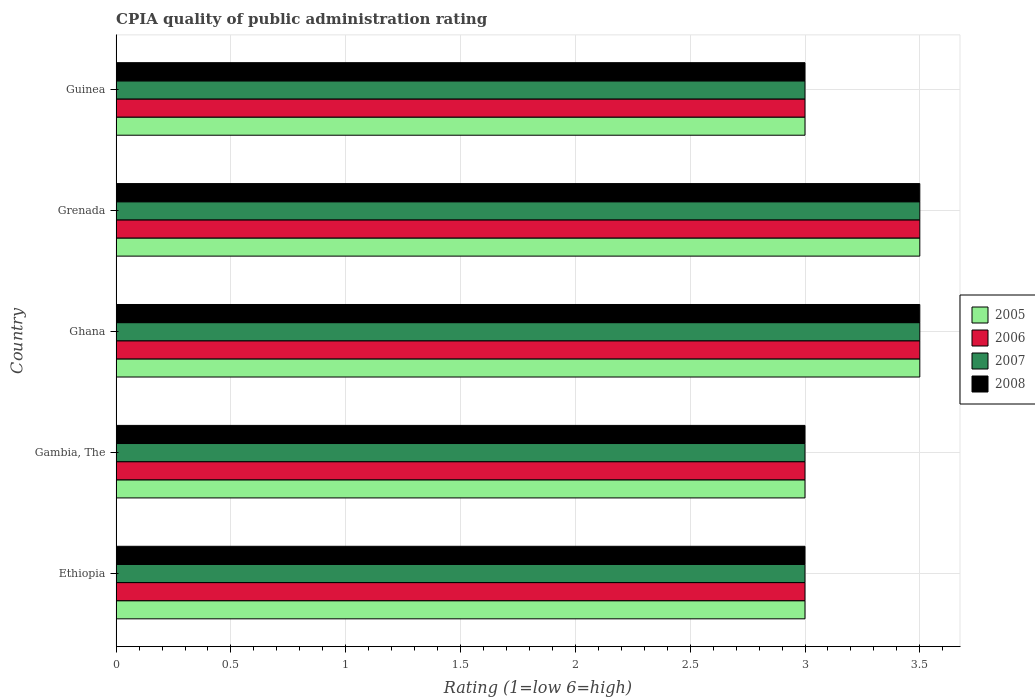Are the number of bars per tick equal to the number of legend labels?
Ensure brevity in your answer.  Yes. How many bars are there on the 4th tick from the top?
Make the answer very short. 4. How many bars are there on the 3rd tick from the bottom?
Give a very brief answer. 4. What is the label of the 5th group of bars from the top?
Keep it short and to the point. Ethiopia. In which country was the CPIA rating in 2006 maximum?
Your answer should be compact. Ghana. In which country was the CPIA rating in 2006 minimum?
Your answer should be very brief. Ethiopia. What is the total CPIA rating in 2005 in the graph?
Offer a terse response. 16. What is the difference between the CPIA rating in 2005 in Ghana and the CPIA rating in 2006 in Ethiopia?
Your response must be concise. 0.5. What is the average CPIA rating in 2008 per country?
Make the answer very short. 3.2. In how many countries, is the CPIA rating in 2008 greater than 1 ?
Ensure brevity in your answer.  5. What is the ratio of the CPIA rating in 2005 in Ethiopia to that in Ghana?
Provide a short and direct response. 0.86. Is the CPIA rating in 2007 in Ghana less than that in Grenada?
Your response must be concise. No. Is the sum of the CPIA rating in 2006 in Ethiopia and Grenada greater than the maximum CPIA rating in 2008 across all countries?
Make the answer very short. Yes. Is it the case that in every country, the sum of the CPIA rating in 2005 and CPIA rating in 2006 is greater than the sum of CPIA rating in 2008 and CPIA rating in 2007?
Offer a terse response. No. What does the 1st bar from the bottom in Grenada represents?
Offer a very short reply. 2005. How many bars are there?
Provide a succinct answer. 20. How many countries are there in the graph?
Provide a short and direct response. 5. Are the values on the major ticks of X-axis written in scientific E-notation?
Your response must be concise. No. Does the graph contain any zero values?
Keep it short and to the point. No. Does the graph contain grids?
Provide a short and direct response. Yes. What is the title of the graph?
Offer a terse response. CPIA quality of public administration rating. Does "2013" appear as one of the legend labels in the graph?
Give a very brief answer. No. What is the Rating (1=low 6=high) of 2005 in Ethiopia?
Offer a terse response. 3. What is the Rating (1=low 6=high) of 2008 in Ethiopia?
Your answer should be compact. 3. What is the Rating (1=low 6=high) in 2005 in Gambia, The?
Keep it short and to the point. 3. What is the Rating (1=low 6=high) of 2008 in Gambia, The?
Ensure brevity in your answer.  3. What is the Rating (1=low 6=high) of 2008 in Ghana?
Your answer should be very brief. 3.5. What is the Rating (1=low 6=high) of 2005 in Guinea?
Give a very brief answer. 3. What is the Rating (1=low 6=high) of 2007 in Guinea?
Your response must be concise. 3. Across all countries, what is the maximum Rating (1=low 6=high) of 2005?
Your response must be concise. 3.5. Across all countries, what is the maximum Rating (1=low 6=high) of 2006?
Give a very brief answer. 3.5. Across all countries, what is the maximum Rating (1=low 6=high) of 2008?
Your answer should be compact. 3.5. Across all countries, what is the minimum Rating (1=low 6=high) in 2006?
Ensure brevity in your answer.  3. Across all countries, what is the minimum Rating (1=low 6=high) in 2007?
Give a very brief answer. 3. Across all countries, what is the minimum Rating (1=low 6=high) of 2008?
Offer a terse response. 3. What is the total Rating (1=low 6=high) of 2005 in the graph?
Ensure brevity in your answer.  16. What is the total Rating (1=low 6=high) in 2006 in the graph?
Provide a short and direct response. 16. What is the total Rating (1=low 6=high) of 2007 in the graph?
Make the answer very short. 16. What is the total Rating (1=low 6=high) of 2008 in the graph?
Offer a terse response. 16. What is the difference between the Rating (1=low 6=high) of 2006 in Ethiopia and that in Gambia, The?
Your answer should be very brief. 0. What is the difference between the Rating (1=low 6=high) in 2007 in Ethiopia and that in Gambia, The?
Keep it short and to the point. 0. What is the difference between the Rating (1=low 6=high) in 2007 in Ethiopia and that in Ghana?
Make the answer very short. -0.5. What is the difference between the Rating (1=low 6=high) of 2005 in Ethiopia and that in Grenada?
Offer a very short reply. -0.5. What is the difference between the Rating (1=low 6=high) of 2006 in Ethiopia and that in Grenada?
Ensure brevity in your answer.  -0.5. What is the difference between the Rating (1=low 6=high) in 2007 in Ethiopia and that in Grenada?
Offer a very short reply. -0.5. What is the difference between the Rating (1=low 6=high) of 2005 in Ethiopia and that in Guinea?
Ensure brevity in your answer.  0. What is the difference between the Rating (1=low 6=high) in 2008 in Ethiopia and that in Guinea?
Provide a succinct answer. 0. What is the difference between the Rating (1=low 6=high) of 2006 in Gambia, The and that in Ghana?
Ensure brevity in your answer.  -0.5. What is the difference between the Rating (1=low 6=high) of 2007 in Gambia, The and that in Grenada?
Provide a short and direct response. -0.5. What is the difference between the Rating (1=low 6=high) in 2005 in Gambia, The and that in Guinea?
Offer a terse response. 0. What is the difference between the Rating (1=low 6=high) of 2005 in Ghana and that in Grenada?
Your answer should be compact. 0. What is the difference between the Rating (1=low 6=high) of 2007 in Ghana and that in Grenada?
Give a very brief answer. 0. What is the difference between the Rating (1=low 6=high) in 2007 in Ghana and that in Guinea?
Keep it short and to the point. 0.5. What is the difference between the Rating (1=low 6=high) in 2005 in Grenada and that in Guinea?
Provide a succinct answer. 0.5. What is the difference between the Rating (1=low 6=high) in 2007 in Grenada and that in Guinea?
Your answer should be compact. 0.5. What is the difference between the Rating (1=low 6=high) in 2005 in Ethiopia and the Rating (1=low 6=high) in 2006 in Gambia, The?
Make the answer very short. 0. What is the difference between the Rating (1=low 6=high) of 2005 in Ethiopia and the Rating (1=low 6=high) of 2007 in Gambia, The?
Provide a succinct answer. 0. What is the difference between the Rating (1=low 6=high) in 2006 in Ethiopia and the Rating (1=low 6=high) in 2007 in Gambia, The?
Your answer should be compact. 0. What is the difference between the Rating (1=low 6=high) in 2006 in Ethiopia and the Rating (1=low 6=high) in 2008 in Gambia, The?
Make the answer very short. 0. What is the difference between the Rating (1=low 6=high) of 2007 in Ethiopia and the Rating (1=low 6=high) of 2008 in Gambia, The?
Your answer should be compact. 0. What is the difference between the Rating (1=low 6=high) in 2005 in Ethiopia and the Rating (1=low 6=high) in 2007 in Ghana?
Provide a short and direct response. -0.5. What is the difference between the Rating (1=low 6=high) in 2006 in Ethiopia and the Rating (1=low 6=high) in 2007 in Ghana?
Your answer should be very brief. -0.5. What is the difference between the Rating (1=low 6=high) in 2006 in Ethiopia and the Rating (1=low 6=high) in 2008 in Ghana?
Give a very brief answer. -0.5. What is the difference between the Rating (1=low 6=high) of 2007 in Ethiopia and the Rating (1=low 6=high) of 2008 in Ghana?
Provide a succinct answer. -0.5. What is the difference between the Rating (1=low 6=high) in 2005 in Ethiopia and the Rating (1=low 6=high) in 2007 in Grenada?
Keep it short and to the point. -0.5. What is the difference between the Rating (1=low 6=high) in 2006 in Ethiopia and the Rating (1=low 6=high) in 2007 in Grenada?
Keep it short and to the point. -0.5. What is the difference between the Rating (1=low 6=high) in 2006 in Ethiopia and the Rating (1=low 6=high) in 2008 in Grenada?
Give a very brief answer. -0.5. What is the difference between the Rating (1=low 6=high) of 2007 in Ethiopia and the Rating (1=low 6=high) of 2008 in Grenada?
Make the answer very short. -0.5. What is the difference between the Rating (1=low 6=high) in 2005 in Ethiopia and the Rating (1=low 6=high) in 2007 in Guinea?
Your answer should be very brief. 0. What is the difference between the Rating (1=low 6=high) of 2005 in Ethiopia and the Rating (1=low 6=high) of 2008 in Guinea?
Make the answer very short. 0. What is the difference between the Rating (1=low 6=high) of 2006 in Ethiopia and the Rating (1=low 6=high) of 2007 in Guinea?
Ensure brevity in your answer.  0. What is the difference between the Rating (1=low 6=high) in 2007 in Gambia, The and the Rating (1=low 6=high) in 2008 in Ghana?
Your response must be concise. -0.5. What is the difference between the Rating (1=low 6=high) of 2005 in Gambia, The and the Rating (1=low 6=high) of 2006 in Grenada?
Offer a very short reply. -0.5. What is the difference between the Rating (1=low 6=high) in 2005 in Gambia, The and the Rating (1=low 6=high) in 2007 in Grenada?
Ensure brevity in your answer.  -0.5. What is the difference between the Rating (1=low 6=high) in 2005 in Ghana and the Rating (1=low 6=high) in 2006 in Grenada?
Offer a terse response. 0. What is the difference between the Rating (1=low 6=high) in 2005 in Ghana and the Rating (1=low 6=high) in 2007 in Grenada?
Your response must be concise. 0. What is the difference between the Rating (1=low 6=high) of 2006 in Ghana and the Rating (1=low 6=high) of 2008 in Grenada?
Provide a succinct answer. 0. What is the difference between the Rating (1=low 6=high) in 2007 in Ghana and the Rating (1=low 6=high) in 2008 in Grenada?
Provide a short and direct response. 0. What is the difference between the Rating (1=low 6=high) in 2005 in Ghana and the Rating (1=low 6=high) in 2006 in Guinea?
Offer a terse response. 0.5. What is the difference between the Rating (1=low 6=high) in 2005 in Ghana and the Rating (1=low 6=high) in 2007 in Guinea?
Ensure brevity in your answer.  0.5. What is the difference between the Rating (1=low 6=high) in 2005 in Ghana and the Rating (1=low 6=high) in 2008 in Guinea?
Your answer should be compact. 0.5. What is the difference between the Rating (1=low 6=high) in 2006 in Ghana and the Rating (1=low 6=high) in 2008 in Guinea?
Ensure brevity in your answer.  0.5. What is the difference between the Rating (1=low 6=high) of 2007 in Ghana and the Rating (1=low 6=high) of 2008 in Guinea?
Your answer should be very brief. 0.5. What is the difference between the Rating (1=low 6=high) of 2005 in Grenada and the Rating (1=low 6=high) of 2007 in Guinea?
Give a very brief answer. 0.5. What is the difference between the Rating (1=low 6=high) in 2006 in Grenada and the Rating (1=low 6=high) in 2007 in Guinea?
Give a very brief answer. 0.5. What is the difference between the Rating (1=low 6=high) of 2006 in Grenada and the Rating (1=low 6=high) of 2008 in Guinea?
Your answer should be compact. 0.5. What is the average Rating (1=low 6=high) in 2006 per country?
Offer a very short reply. 3.2. What is the average Rating (1=low 6=high) in 2008 per country?
Your answer should be compact. 3.2. What is the difference between the Rating (1=low 6=high) of 2005 and Rating (1=low 6=high) of 2006 in Ethiopia?
Provide a succinct answer. 0. What is the difference between the Rating (1=low 6=high) in 2005 and Rating (1=low 6=high) in 2007 in Gambia, The?
Keep it short and to the point. 0. What is the difference between the Rating (1=low 6=high) of 2005 and Rating (1=low 6=high) of 2008 in Gambia, The?
Make the answer very short. 0. What is the difference between the Rating (1=low 6=high) in 2006 and Rating (1=low 6=high) in 2008 in Gambia, The?
Your response must be concise. 0. What is the difference between the Rating (1=low 6=high) in 2005 and Rating (1=low 6=high) in 2006 in Ghana?
Offer a very short reply. 0. What is the difference between the Rating (1=low 6=high) in 2005 and Rating (1=low 6=high) in 2007 in Ghana?
Offer a terse response. 0. What is the difference between the Rating (1=low 6=high) of 2006 and Rating (1=low 6=high) of 2007 in Ghana?
Provide a short and direct response. 0. What is the difference between the Rating (1=low 6=high) of 2007 and Rating (1=low 6=high) of 2008 in Ghana?
Keep it short and to the point. 0. What is the difference between the Rating (1=low 6=high) of 2005 and Rating (1=low 6=high) of 2008 in Grenada?
Your answer should be compact. 0. What is the difference between the Rating (1=low 6=high) in 2006 and Rating (1=low 6=high) in 2007 in Grenada?
Keep it short and to the point. 0. What is the difference between the Rating (1=low 6=high) in 2006 and Rating (1=low 6=high) in 2008 in Grenada?
Give a very brief answer. 0. What is the difference between the Rating (1=low 6=high) in 2007 and Rating (1=low 6=high) in 2008 in Grenada?
Make the answer very short. 0. What is the difference between the Rating (1=low 6=high) of 2005 and Rating (1=low 6=high) of 2007 in Guinea?
Keep it short and to the point. 0. What is the difference between the Rating (1=low 6=high) of 2005 and Rating (1=low 6=high) of 2008 in Guinea?
Your response must be concise. 0. What is the difference between the Rating (1=low 6=high) in 2006 and Rating (1=low 6=high) in 2007 in Guinea?
Offer a very short reply. 0. What is the difference between the Rating (1=low 6=high) of 2006 and Rating (1=low 6=high) of 2008 in Guinea?
Ensure brevity in your answer.  0. What is the difference between the Rating (1=low 6=high) in 2007 and Rating (1=low 6=high) in 2008 in Guinea?
Provide a short and direct response. 0. What is the ratio of the Rating (1=low 6=high) of 2006 in Ethiopia to that in Gambia, The?
Give a very brief answer. 1. What is the ratio of the Rating (1=low 6=high) in 2007 in Ethiopia to that in Gambia, The?
Give a very brief answer. 1. What is the ratio of the Rating (1=low 6=high) in 2008 in Ethiopia to that in Gambia, The?
Keep it short and to the point. 1. What is the ratio of the Rating (1=low 6=high) in 2005 in Ethiopia to that in Ghana?
Make the answer very short. 0.86. What is the ratio of the Rating (1=low 6=high) of 2008 in Ethiopia to that in Ghana?
Ensure brevity in your answer.  0.86. What is the ratio of the Rating (1=low 6=high) in 2005 in Ethiopia to that in Grenada?
Offer a terse response. 0.86. What is the ratio of the Rating (1=low 6=high) of 2006 in Ethiopia to that in Grenada?
Ensure brevity in your answer.  0.86. What is the ratio of the Rating (1=low 6=high) in 2008 in Ethiopia to that in Grenada?
Ensure brevity in your answer.  0.86. What is the ratio of the Rating (1=low 6=high) of 2005 in Ethiopia to that in Guinea?
Make the answer very short. 1. What is the ratio of the Rating (1=low 6=high) of 2006 in Ethiopia to that in Guinea?
Your answer should be compact. 1. What is the ratio of the Rating (1=low 6=high) in 2008 in Ethiopia to that in Guinea?
Offer a terse response. 1. What is the ratio of the Rating (1=low 6=high) in 2005 in Gambia, The to that in Ghana?
Your answer should be compact. 0.86. What is the ratio of the Rating (1=low 6=high) of 2006 in Gambia, The to that in Ghana?
Provide a succinct answer. 0.86. What is the ratio of the Rating (1=low 6=high) in 2005 in Gambia, The to that in Grenada?
Provide a succinct answer. 0.86. What is the ratio of the Rating (1=low 6=high) in 2008 in Gambia, The to that in Grenada?
Your answer should be compact. 0.86. What is the ratio of the Rating (1=low 6=high) in 2005 in Gambia, The to that in Guinea?
Give a very brief answer. 1. What is the ratio of the Rating (1=low 6=high) of 2006 in Gambia, The to that in Guinea?
Your answer should be very brief. 1. What is the ratio of the Rating (1=low 6=high) of 2008 in Gambia, The to that in Guinea?
Give a very brief answer. 1. What is the ratio of the Rating (1=low 6=high) of 2005 in Ghana to that in Grenada?
Offer a terse response. 1. What is the ratio of the Rating (1=low 6=high) of 2006 in Ghana to that in Grenada?
Offer a terse response. 1. What is the ratio of the Rating (1=low 6=high) in 2007 in Ghana to that in Grenada?
Provide a succinct answer. 1. What is the ratio of the Rating (1=low 6=high) of 2006 in Ghana to that in Guinea?
Keep it short and to the point. 1.17. What is the ratio of the Rating (1=low 6=high) of 2007 in Ghana to that in Guinea?
Your answer should be compact. 1.17. What is the ratio of the Rating (1=low 6=high) of 2008 in Ghana to that in Guinea?
Provide a short and direct response. 1.17. What is the ratio of the Rating (1=low 6=high) in 2006 in Grenada to that in Guinea?
Your answer should be compact. 1.17. What is the difference between the highest and the second highest Rating (1=low 6=high) of 2005?
Keep it short and to the point. 0. What is the difference between the highest and the second highest Rating (1=low 6=high) of 2008?
Ensure brevity in your answer.  0. What is the difference between the highest and the lowest Rating (1=low 6=high) in 2008?
Offer a terse response. 0.5. 